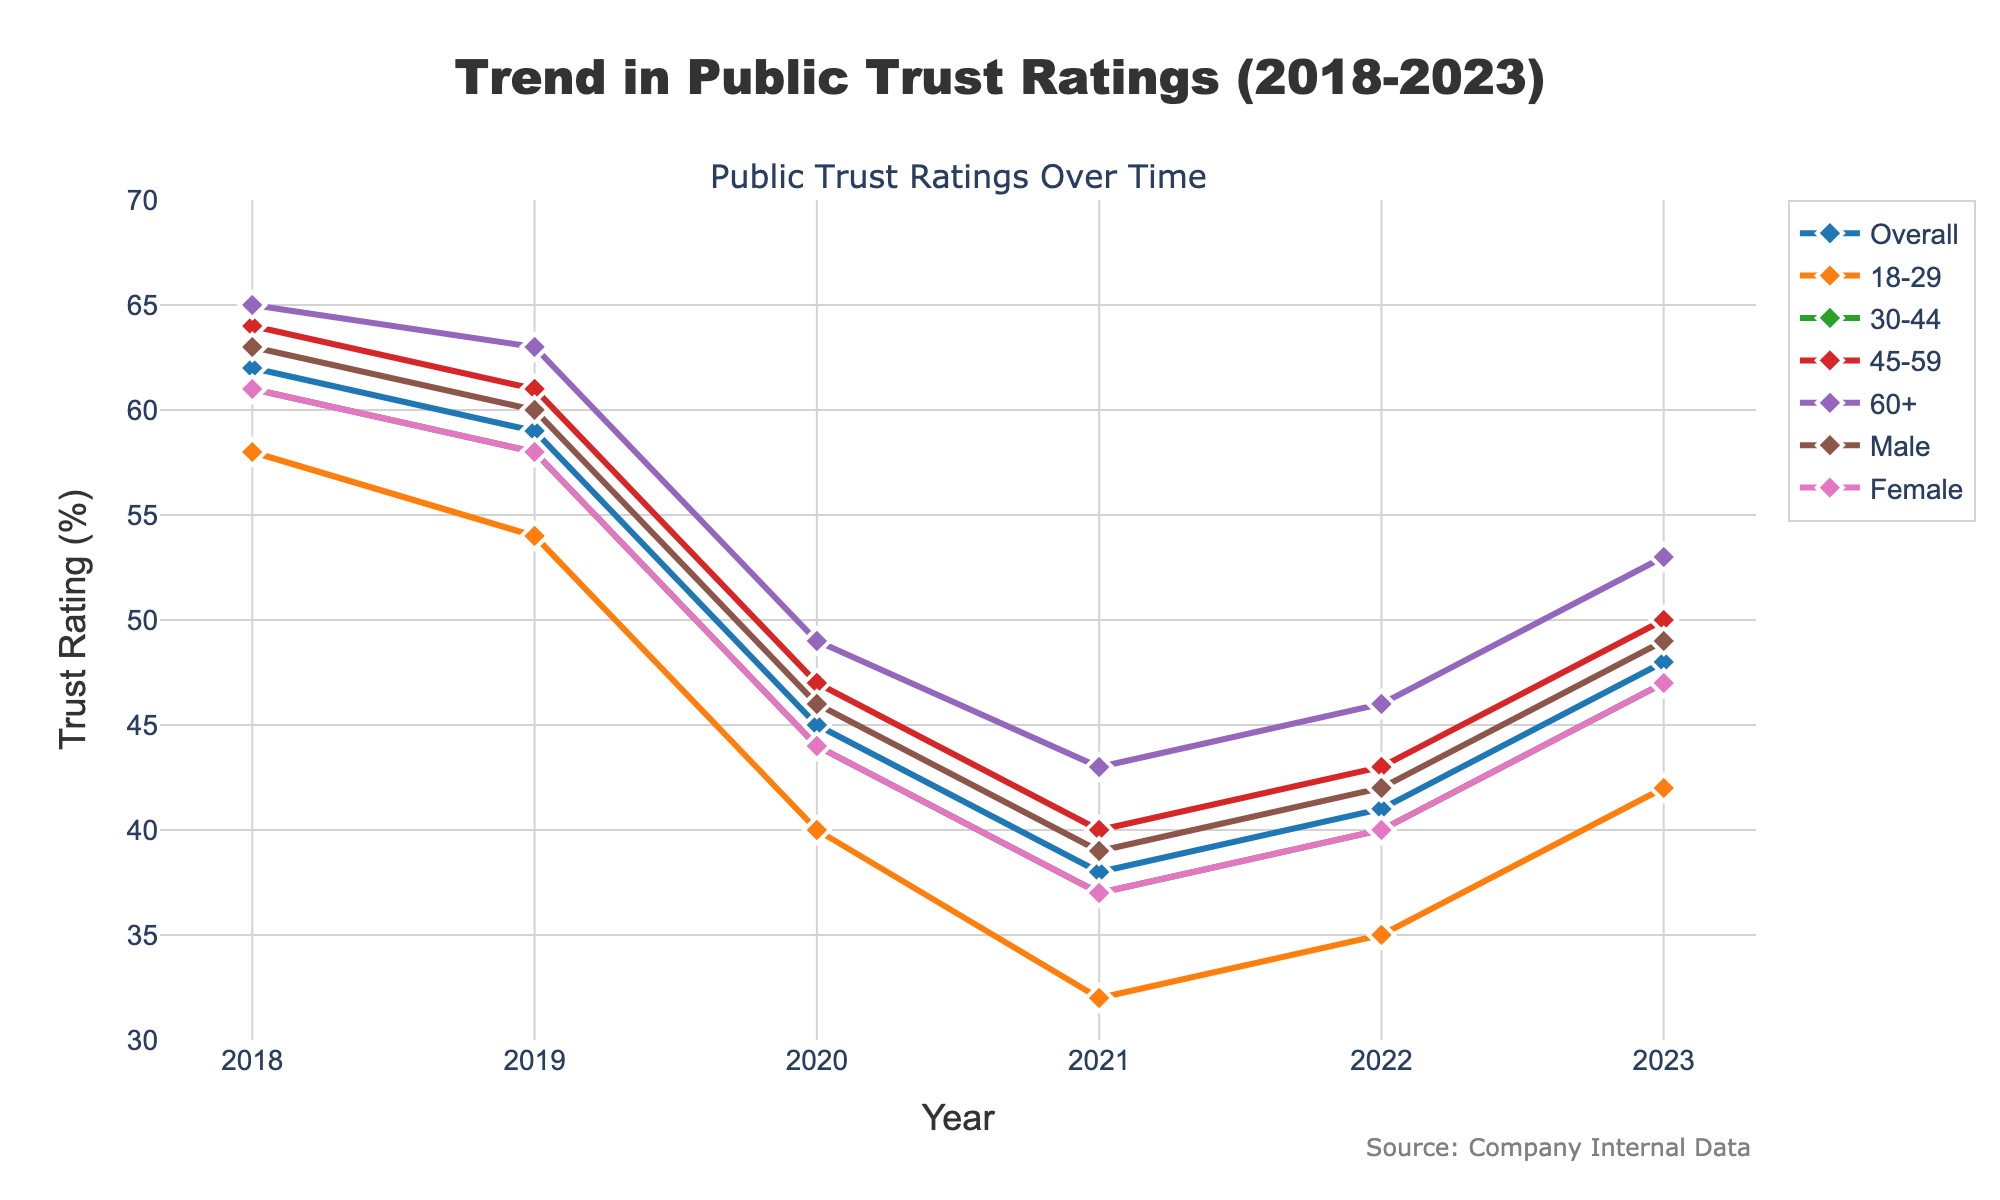What's the overall trend in trust ratings for the company from 2018 to 2023? Look at the line labeled "Overall" and observe the change from 2018 to 2023. Trust ratings decline from 62% in 2018 to a low of 38% in 2021, then rise again to 48% in 2023.
Answer: Decline then rise Which demographic group had the lowest trust rating in 2021? Find the lowest point in 2021 across all demographic lines. The "18-29" group had the lowest rating at 32%.
Answer: 18-29 By how much did the trust rating for females change from 2021 to 2023? Check the "Female" line and see the points for 2021 and 2023. It rose from 37% in 2021 to 47% in 2023. The change is 47 - 37.
Answer: 10% Which year showed the biggest decline in trust ratings for the "30-44" group? Observe the year-to-year changes in the "30-44" line. The largest decline happened from 2019 (58%) to 2020 (44%), a drop of 14%.
Answer: 2020 Which gender group has a higher trust rating in 2023, and by how much? Compare the ratings for "Male" and "Female" in 2023. Males are at 49% and females at 47%, so males are higher by 49 - 47.
Answer: Male by 2% What is the average trust rating for the "60+" group from 2018 to 2023? Sum the trust ratings for "60+" from each year and divide by the number of years: (65 + 63 + 49 + 43 + 46 + 53) / 6.
Answer: 53.17% Which demographic showed the greatest recovery in trust ratings from 2021 to 2023? Look at the increase from 2021 to 2023 for all groups. The "18-29" group went from 32% to 42%, an increase of 10%. This is the largest increase.
Answer: 18-29 How did the trust ratings for the "Overall" category compare between 2018 and 2022? Compare the "Overall" trust ratings in 2018 and 2022: they fell from 62% to 41%, a decrease of 62 - 41.
Answer: Decreased by 21% Which demographic group had the highest rating in 2023? Check the trust ratings in 2023 across all demographic lines. The "60+" group has the highest at 53%.
Answer: 60+ Between which years did the "Male" trust rating see a rise and a fall? Examine the "Male" trust rating line to identify segments of change. There is a fall from 2018 (63%) to 2021 (39%) and then a rise from 2021 (39%) to 2023 (49%).
Answer: Fall from 2018 to 2021, rise from 2021 to 2023 